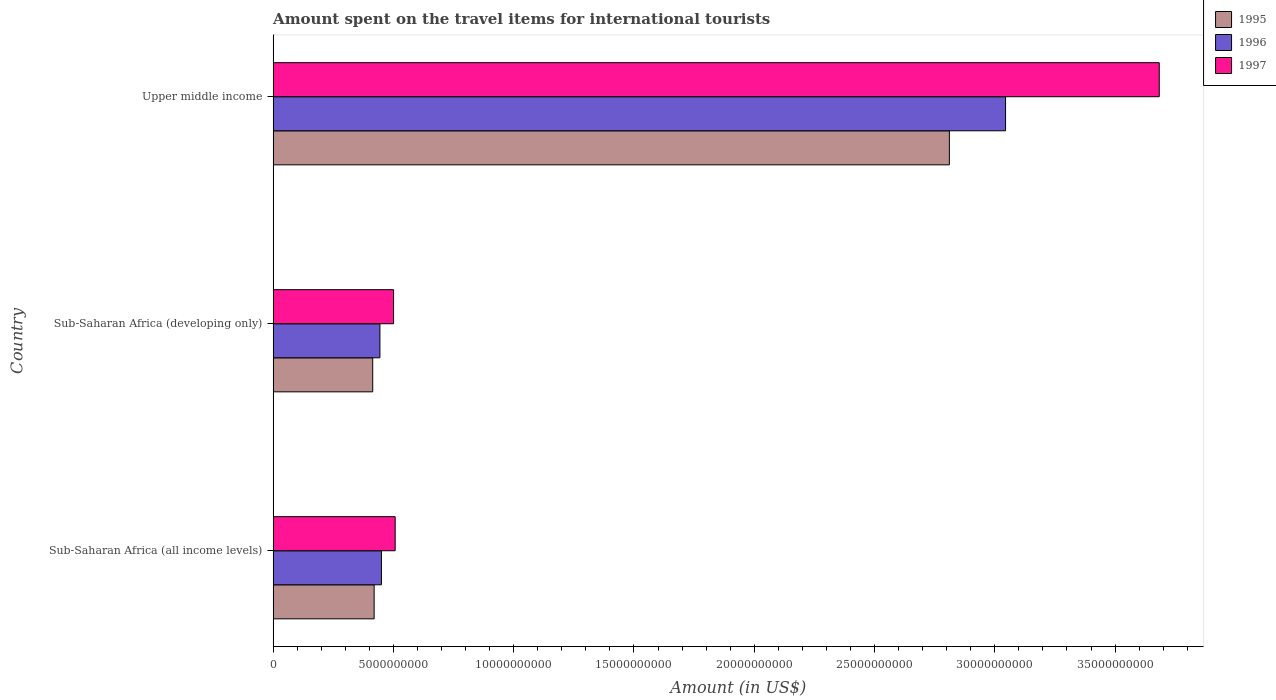What is the label of the 1st group of bars from the top?
Keep it short and to the point. Upper middle income. In how many cases, is the number of bars for a given country not equal to the number of legend labels?
Provide a short and direct response. 0. What is the amount spent on the travel items for international tourists in 1997 in Upper middle income?
Provide a short and direct response. 3.68e+1. Across all countries, what is the maximum amount spent on the travel items for international tourists in 1996?
Provide a short and direct response. 3.04e+1. Across all countries, what is the minimum amount spent on the travel items for international tourists in 1995?
Provide a short and direct response. 4.14e+09. In which country was the amount spent on the travel items for international tourists in 1996 maximum?
Your answer should be very brief. Upper middle income. In which country was the amount spent on the travel items for international tourists in 1997 minimum?
Make the answer very short. Sub-Saharan Africa (developing only). What is the total amount spent on the travel items for international tourists in 1997 in the graph?
Provide a short and direct response. 4.69e+1. What is the difference between the amount spent on the travel items for international tourists in 1996 in Sub-Saharan Africa (all income levels) and that in Sub-Saharan Africa (developing only)?
Keep it short and to the point. 6.18e+07. What is the difference between the amount spent on the travel items for international tourists in 1995 in Sub-Saharan Africa (developing only) and the amount spent on the travel items for international tourists in 1996 in Sub-Saharan Africa (all income levels)?
Keep it short and to the point. -3.62e+08. What is the average amount spent on the travel items for international tourists in 1995 per country?
Give a very brief answer. 1.22e+1. What is the difference between the amount spent on the travel items for international tourists in 1996 and amount spent on the travel items for international tourists in 1995 in Upper middle income?
Offer a terse response. 2.34e+09. In how many countries, is the amount spent on the travel items for international tourists in 1995 greater than 24000000000 US$?
Provide a succinct answer. 1. What is the ratio of the amount spent on the travel items for international tourists in 1996 in Sub-Saharan Africa (developing only) to that in Upper middle income?
Your answer should be very brief. 0.15. Is the amount spent on the travel items for international tourists in 1997 in Sub-Saharan Africa (all income levels) less than that in Sub-Saharan Africa (developing only)?
Provide a short and direct response. No. What is the difference between the highest and the second highest amount spent on the travel items for international tourists in 1996?
Make the answer very short. 2.59e+1. What is the difference between the highest and the lowest amount spent on the travel items for international tourists in 1995?
Your answer should be very brief. 2.40e+1. What does the 3rd bar from the top in Upper middle income represents?
Offer a terse response. 1995. What does the 3rd bar from the bottom in Sub-Saharan Africa (developing only) represents?
Keep it short and to the point. 1997. Is it the case that in every country, the sum of the amount spent on the travel items for international tourists in 1997 and amount spent on the travel items for international tourists in 1995 is greater than the amount spent on the travel items for international tourists in 1996?
Provide a succinct answer. Yes. What is the difference between two consecutive major ticks on the X-axis?
Your answer should be very brief. 5.00e+09. Are the values on the major ticks of X-axis written in scientific E-notation?
Make the answer very short. No. Does the graph contain grids?
Your answer should be compact. No. Where does the legend appear in the graph?
Give a very brief answer. Top right. How many legend labels are there?
Offer a terse response. 3. How are the legend labels stacked?
Provide a short and direct response. Vertical. What is the title of the graph?
Offer a very short reply. Amount spent on the travel items for international tourists. What is the label or title of the X-axis?
Give a very brief answer. Amount (in US$). What is the label or title of the Y-axis?
Your answer should be very brief. Country. What is the Amount (in US$) in 1995 in Sub-Saharan Africa (all income levels)?
Ensure brevity in your answer.  4.20e+09. What is the Amount (in US$) in 1996 in Sub-Saharan Africa (all income levels)?
Offer a very short reply. 4.50e+09. What is the Amount (in US$) of 1997 in Sub-Saharan Africa (all income levels)?
Your response must be concise. 5.07e+09. What is the Amount (in US$) of 1995 in Sub-Saharan Africa (developing only)?
Ensure brevity in your answer.  4.14e+09. What is the Amount (in US$) of 1996 in Sub-Saharan Africa (developing only)?
Your response must be concise. 4.44e+09. What is the Amount (in US$) in 1997 in Sub-Saharan Africa (developing only)?
Your answer should be very brief. 5.01e+09. What is the Amount (in US$) of 1995 in Upper middle income?
Provide a short and direct response. 2.81e+1. What is the Amount (in US$) of 1996 in Upper middle income?
Offer a very short reply. 3.04e+1. What is the Amount (in US$) of 1997 in Upper middle income?
Offer a very short reply. 3.68e+1. Across all countries, what is the maximum Amount (in US$) in 1995?
Provide a short and direct response. 2.81e+1. Across all countries, what is the maximum Amount (in US$) of 1996?
Your response must be concise. 3.04e+1. Across all countries, what is the maximum Amount (in US$) of 1997?
Your answer should be compact. 3.68e+1. Across all countries, what is the minimum Amount (in US$) of 1995?
Keep it short and to the point. 4.14e+09. Across all countries, what is the minimum Amount (in US$) of 1996?
Your answer should be compact. 4.44e+09. Across all countries, what is the minimum Amount (in US$) in 1997?
Provide a short and direct response. 5.01e+09. What is the total Amount (in US$) of 1995 in the graph?
Your answer should be very brief. 3.65e+1. What is the total Amount (in US$) in 1996 in the graph?
Make the answer very short. 3.94e+1. What is the total Amount (in US$) of 1997 in the graph?
Your answer should be compact. 4.69e+1. What is the difference between the Amount (in US$) in 1995 in Sub-Saharan Africa (all income levels) and that in Sub-Saharan Africa (developing only)?
Your response must be concise. 5.93e+07. What is the difference between the Amount (in US$) in 1996 in Sub-Saharan Africa (all income levels) and that in Sub-Saharan Africa (developing only)?
Offer a terse response. 6.18e+07. What is the difference between the Amount (in US$) of 1997 in Sub-Saharan Africa (all income levels) and that in Sub-Saharan Africa (developing only)?
Provide a succinct answer. 6.67e+07. What is the difference between the Amount (in US$) in 1995 in Sub-Saharan Africa (all income levels) and that in Upper middle income?
Provide a short and direct response. -2.39e+1. What is the difference between the Amount (in US$) in 1996 in Sub-Saharan Africa (all income levels) and that in Upper middle income?
Your response must be concise. -2.59e+1. What is the difference between the Amount (in US$) of 1997 in Sub-Saharan Africa (all income levels) and that in Upper middle income?
Offer a terse response. -3.18e+1. What is the difference between the Amount (in US$) in 1995 in Sub-Saharan Africa (developing only) and that in Upper middle income?
Make the answer very short. -2.40e+1. What is the difference between the Amount (in US$) of 1996 in Sub-Saharan Africa (developing only) and that in Upper middle income?
Offer a very short reply. -2.60e+1. What is the difference between the Amount (in US$) in 1997 in Sub-Saharan Africa (developing only) and that in Upper middle income?
Offer a very short reply. -3.18e+1. What is the difference between the Amount (in US$) of 1995 in Sub-Saharan Africa (all income levels) and the Amount (in US$) of 1996 in Sub-Saharan Africa (developing only)?
Offer a terse response. -2.40e+08. What is the difference between the Amount (in US$) of 1995 in Sub-Saharan Africa (all income levels) and the Amount (in US$) of 1997 in Sub-Saharan Africa (developing only)?
Ensure brevity in your answer.  -8.08e+08. What is the difference between the Amount (in US$) in 1996 in Sub-Saharan Africa (all income levels) and the Amount (in US$) in 1997 in Sub-Saharan Africa (developing only)?
Keep it short and to the point. -5.05e+08. What is the difference between the Amount (in US$) in 1995 in Sub-Saharan Africa (all income levels) and the Amount (in US$) in 1996 in Upper middle income?
Provide a succinct answer. -2.62e+1. What is the difference between the Amount (in US$) in 1995 in Sub-Saharan Africa (all income levels) and the Amount (in US$) in 1997 in Upper middle income?
Keep it short and to the point. -3.26e+1. What is the difference between the Amount (in US$) in 1996 in Sub-Saharan Africa (all income levels) and the Amount (in US$) in 1997 in Upper middle income?
Provide a succinct answer. -3.23e+1. What is the difference between the Amount (in US$) in 1995 in Sub-Saharan Africa (developing only) and the Amount (in US$) in 1996 in Upper middle income?
Your answer should be very brief. -2.63e+1. What is the difference between the Amount (in US$) in 1995 in Sub-Saharan Africa (developing only) and the Amount (in US$) in 1997 in Upper middle income?
Your response must be concise. -3.27e+1. What is the difference between the Amount (in US$) of 1996 in Sub-Saharan Africa (developing only) and the Amount (in US$) of 1997 in Upper middle income?
Ensure brevity in your answer.  -3.24e+1. What is the average Amount (in US$) of 1995 per country?
Offer a very short reply. 1.22e+1. What is the average Amount (in US$) in 1996 per country?
Offer a terse response. 1.31e+1. What is the average Amount (in US$) of 1997 per country?
Offer a terse response. 1.56e+1. What is the difference between the Amount (in US$) in 1995 and Amount (in US$) in 1996 in Sub-Saharan Africa (all income levels)?
Provide a short and direct response. -3.02e+08. What is the difference between the Amount (in US$) in 1995 and Amount (in US$) in 1997 in Sub-Saharan Africa (all income levels)?
Offer a very short reply. -8.74e+08. What is the difference between the Amount (in US$) of 1996 and Amount (in US$) of 1997 in Sub-Saharan Africa (all income levels)?
Provide a short and direct response. -5.72e+08. What is the difference between the Amount (in US$) of 1995 and Amount (in US$) of 1996 in Sub-Saharan Africa (developing only)?
Offer a very short reply. -3.00e+08. What is the difference between the Amount (in US$) of 1995 and Amount (in US$) of 1997 in Sub-Saharan Africa (developing only)?
Offer a terse response. -8.67e+08. What is the difference between the Amount (in US$) of 1996 and Amount (in US$) of 1997 in Sub-Saharan Africa (developing only)?
Your answer should be very brief. -5.67e+08. What is the difference between the Amount (in US$) in 1995 and Amount (in US$) in 1996 in Upper middle income?
Make the answer very short. -2.34e+09. What is the difference between the Amount (in US$) in 1995 and Amount (in US$) in 1997 in Upper middle income?
Provide a succinct answer. -8.72e+09. What is the difference between the Amount (in US$) of 1996 and Amount (in US$) of 1997 in Upper middle income?
Offer a very short reply. -6.39e+09. What is the ratio of the Amount (in US$) in 1995 in Sub-Saharan Africa (all income levels) to that in Sub-Saharan Africa (developing only)?
Your answer should be compact. 1.01. What is the ratio of the Amount (in US$) in 1996 in Sub-Saharan Africa (all income levels) to that in Sub-Saharan Africa (developing only)?
Offer a terse response. 1.01. What is the ratio of the Amount (in US$) in 1997 in Sub-Saharan Africa (all income levels) to that in Sub-Saharan Africa (developing only)?
Ensure brevity in your answer.  1.01. What is the ratio of the Amount (in US$) in 1995 in Sub-Saharan Africa (all income levels) to that in Upper middle income?
Your answer should be compact. 0.15. What is the ratio of the Amount (in US$) in 1996 in Sub-Saharan Africa (all income levels) to that in Upper middle income?
Keep it short and to the point. 0.15. What is the ratio of the Amount (in US$) of 1997 in Sub-Saharan Africa (all income levels) to that in Upper middle income?
Ensure brevity in your answer.  0.14. What is the ratio of the Amount (in US$) of 1995 in Sub-Saharan Africa (developing only) to that in Upper middle income?
Offer a very short reply. 0.15. What is the ratio of the Amount (in US$) in 1996 in Sub-Saharan Africa (developing only) to that in Upper middle income?
Provide a succinct answer. 0.15. What is the ratio of the Amount (in US$) in 1997 in Sub-Saharan Africa (developing only) to that in Upper middle income?
Your response must be concise. 0.14. What is the difference between the highest and the second highest Amount (in US$) in 1995?
Offer a very short reply. 2.39e+1. What is the difference between the highest and the second highest Amount (in US$) of 1996?
Your response must be concise. 2.59e+1. What is the difference between the highest and the second highest Amount (in US$) in 1997?
Your answer should be very brief. 3.18e+1. What is the difference between the highest and the lowest Amount (in US$) of 1995?
Your answer should be compact. 2.40e+1. What is the difference between the highest and the lowest Amount (in US$) in 1996?
Offer a very short reply. 2.60e+1. What is the difference between the highest and the lowest Amount (in US$) in 1997?
Your answer should be compact. 3.18e+1. 